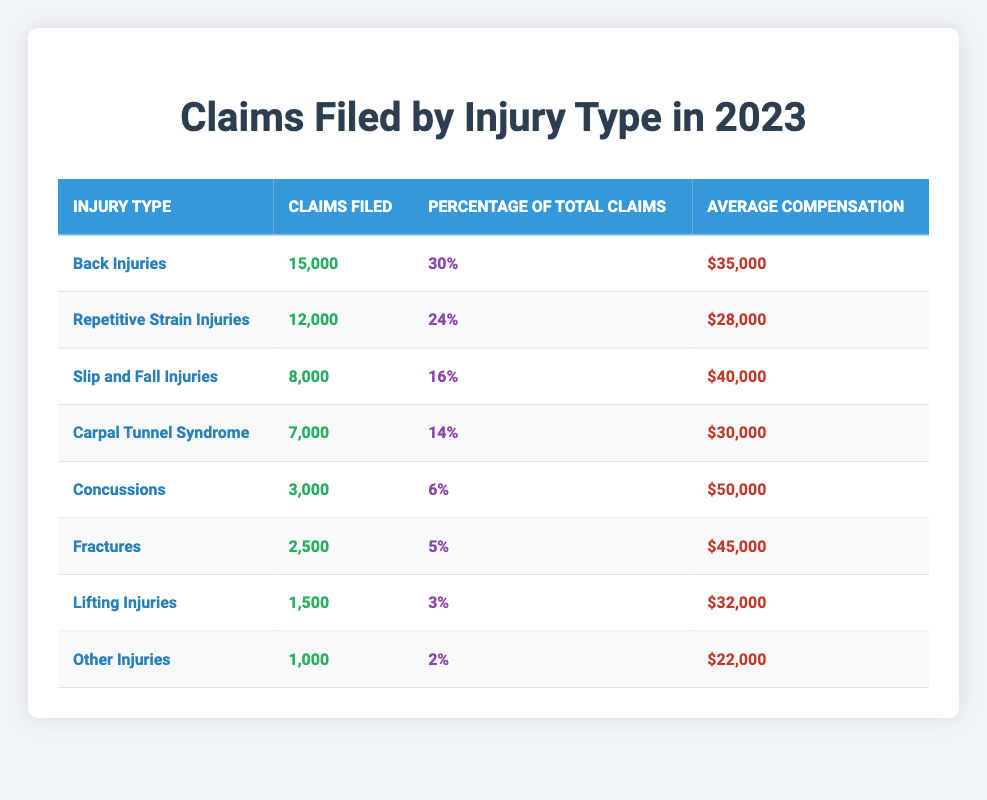What is the injury type with the highest number of claims filed? The table lists the injury types along with the number of claims filed. By inspecting the values, "Back Injuries" has the highest number with 15,000 claims.
Answer: Back Injuries What percentage of total claims do Repetitive Strain Injuries represent? The table shows that Repetitive Strain Injuries account for 24% of the total claims filed.
Answer: 24% How many claims have been filed for Concussions? The table indicates that there were 3,000 claims filed for Concussions in 2023.
Answer: 3,000 Which injury type has the highest average compensation? From the table, Concussions have the highest average compensation at $50,000.
Answer: $50,000 What is the total number of claims filed across all injury types? Adding all the claims gives us 15,000 (Back) + 12,000 (Repetitive Strain) + 8,000 (Slip and Fall) + 7,000 (Carpal Tunnel) + 3,000 (Concussions) + 2,500 (Fractures) + 1,500 (Lifting) + 1,000 (Other) = 49,000 total claims.
Answer: 49,000 How much average compensation do Slip and Fall Injuries receive? The table indicates that the average compensation for Slip and Fall Injuries is $40,000.
Answer: $40,000 Are there more claims filed for Lifting Injuries or Other Injuries? Lifting Injuries have 1,500 claims while Other Injuries have 1,000 claims. Therefore, more claims were filed for Lifting Injuries.
Answer: Yes, Lifting Injuries What is the difference in the average compensation between Fractures and Carpal Tunnel Syndrome? Fractures have an average compensation of $45,000 and Carpal Tunnel Syndrome has $30,000. The difference is $45,000 - $30,000 = $15,000.
Answer: $15,000 How many claims were filed for all types of injuries that fall under less than 10% of total claims? The total claims filed for injuries under 10% include Lifting Injuries (1,500) and Other Injuries (1,000). The total is 1,500 + 1,000 = 2,500 claims.
Answer: 2,500 What is the average claims filed per injury type? There are 8 injury types. The total claims filed are 49,000, so the average is 49,000 / 8 = 6,125 claims per injury type.
Answer: 6,125 